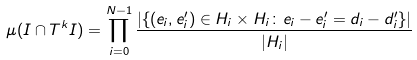Convert formula to latex. <formula><loc_0><loc_0><loc_500><loc_500>\mu ( I \cap T ^ { k } I ) & = \prod _ { i = 0 } ^ { N - 1 } \frac { | \{ ( e _ { i } , e _ { i } ^ { \prime } ) \in H _ { i } \times H _ { i } \colon e _ { i } - e _ { i } ^ { \prime } = d _ { i } - d _ { i } ^ { \prime } \} | } { | H _ { i } | }</formula> 